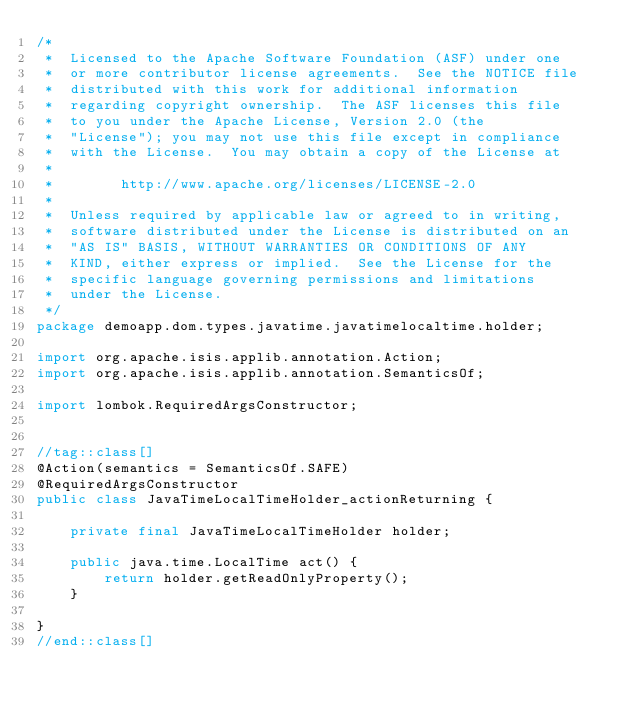<code> <loc_0><loc_0><loc_500><loc_500><_Java_>/*
 *  Licensed to the Apache Software Foundation (ASF) under one
 *  or more contributor license agreements.  See the NOTICE file
 *  distributed with this work for additional information
 *  regarding copyright ownership.  The ASF licenses this file
 *  to you under the Apache License, Version 2.0 (the
 *  "License"); you may not use this file except in compliance
 *  with the License.  You may obtain a copy of the License at
 *
 *        http://www.apache.org/licenses/LICENSE-2.0
 *
 *  Unless required by applicable law or agreed to in writing,
 *  software distributed under the License is distributed on an
 *  "AS IS" BASIS, WITHOUT WARRANTIES OR CONDITIONS OF ANY
 *  KIND, either express or implied.  See the License for the
 *  specific language governing permissions and limitations
 *  under the License.
 */
package demoapp.dom.types.javatime.javatimelocaltime.holder;

import org.apache.isis.applib.annotation.Action;
import org.apache.isis.applib.annotation.SemanticsOf;

import lombok.RequiredArgsConstructor;


//tag::class[]
@Action(semantics = SemanticsOf.SAFE)
@RequiredArgsConstructor
public class JavaTimeLocalTimeHolder_actionReturning {

    private final JavaTimeLocalTimeHolder holder;

    public java.time.LocalTime act() {
        return holder.getReadOnlyProperty();
    }

}
//end::class[]
</code> 